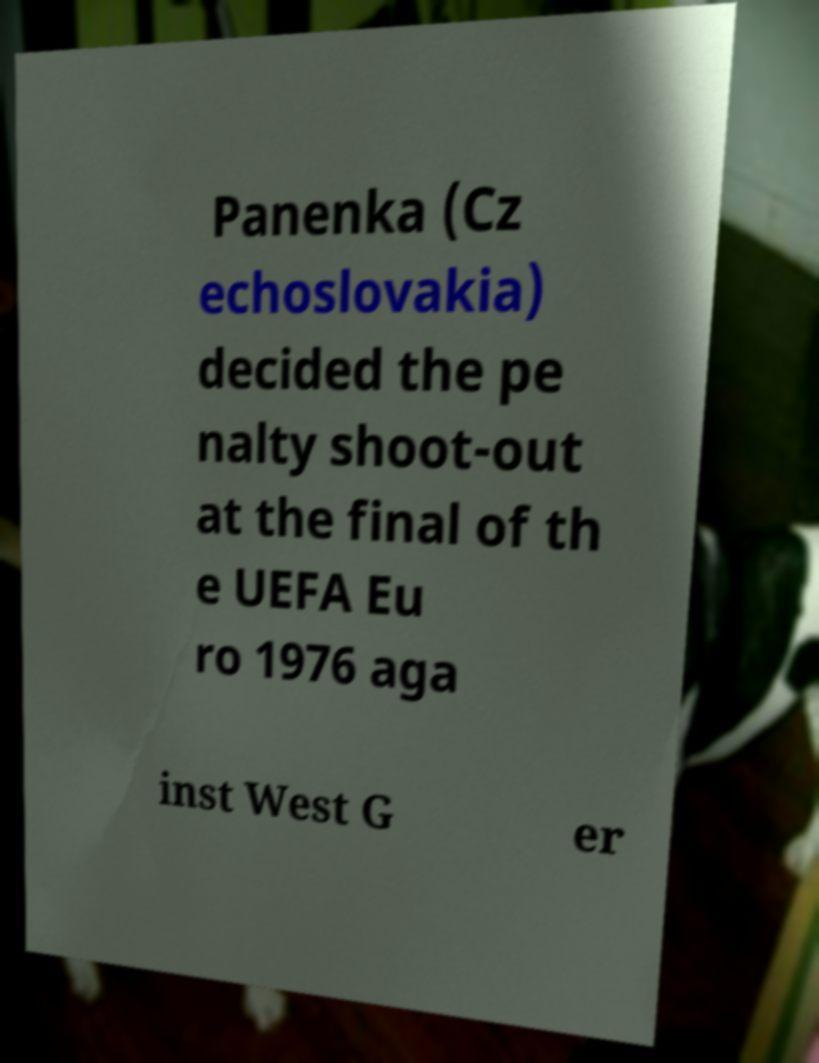I need the written content from this picture converted into text. Can you do that? Panenka (Cz echoslovakia) decided the pe nalty shoot-out at the final of th e UEFA Eu ro 1976 aga inst West G er 